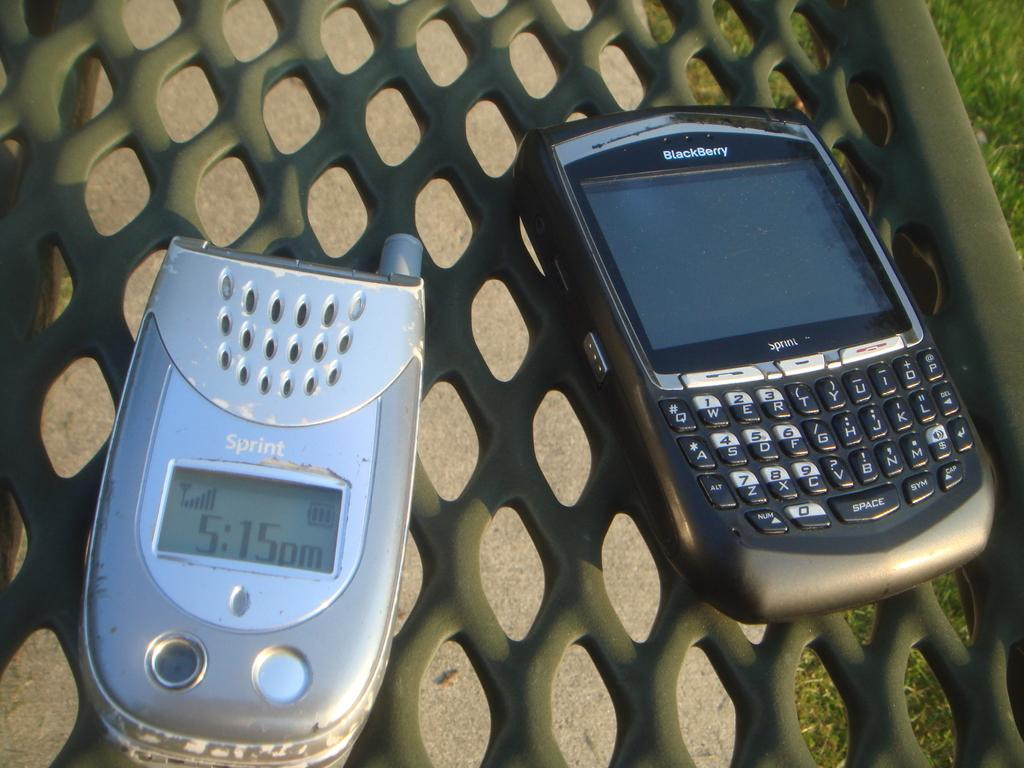<image>
Offer a succinct explanation of the picture presented. Two phones sit side by side, the one on the right is a blackberry. 